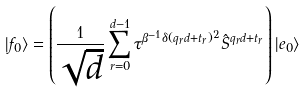<formula> <loc_0><loc_0><loc_500><loc_500>| f _ { 0 } \rangle = \left ( \frac { 1 } { \sqrt { d } } \sum _ { r = 0 } ^ { d - 1 } \tau ^ { \beta ^ { - 1 } \delta ( q _ { r } d + t _ { r } ) ^ { 2 } } \hat { S } ^ { q _ { r } d + t _ { r } } \right ) | e _ { 0 } \rangle</formula> 